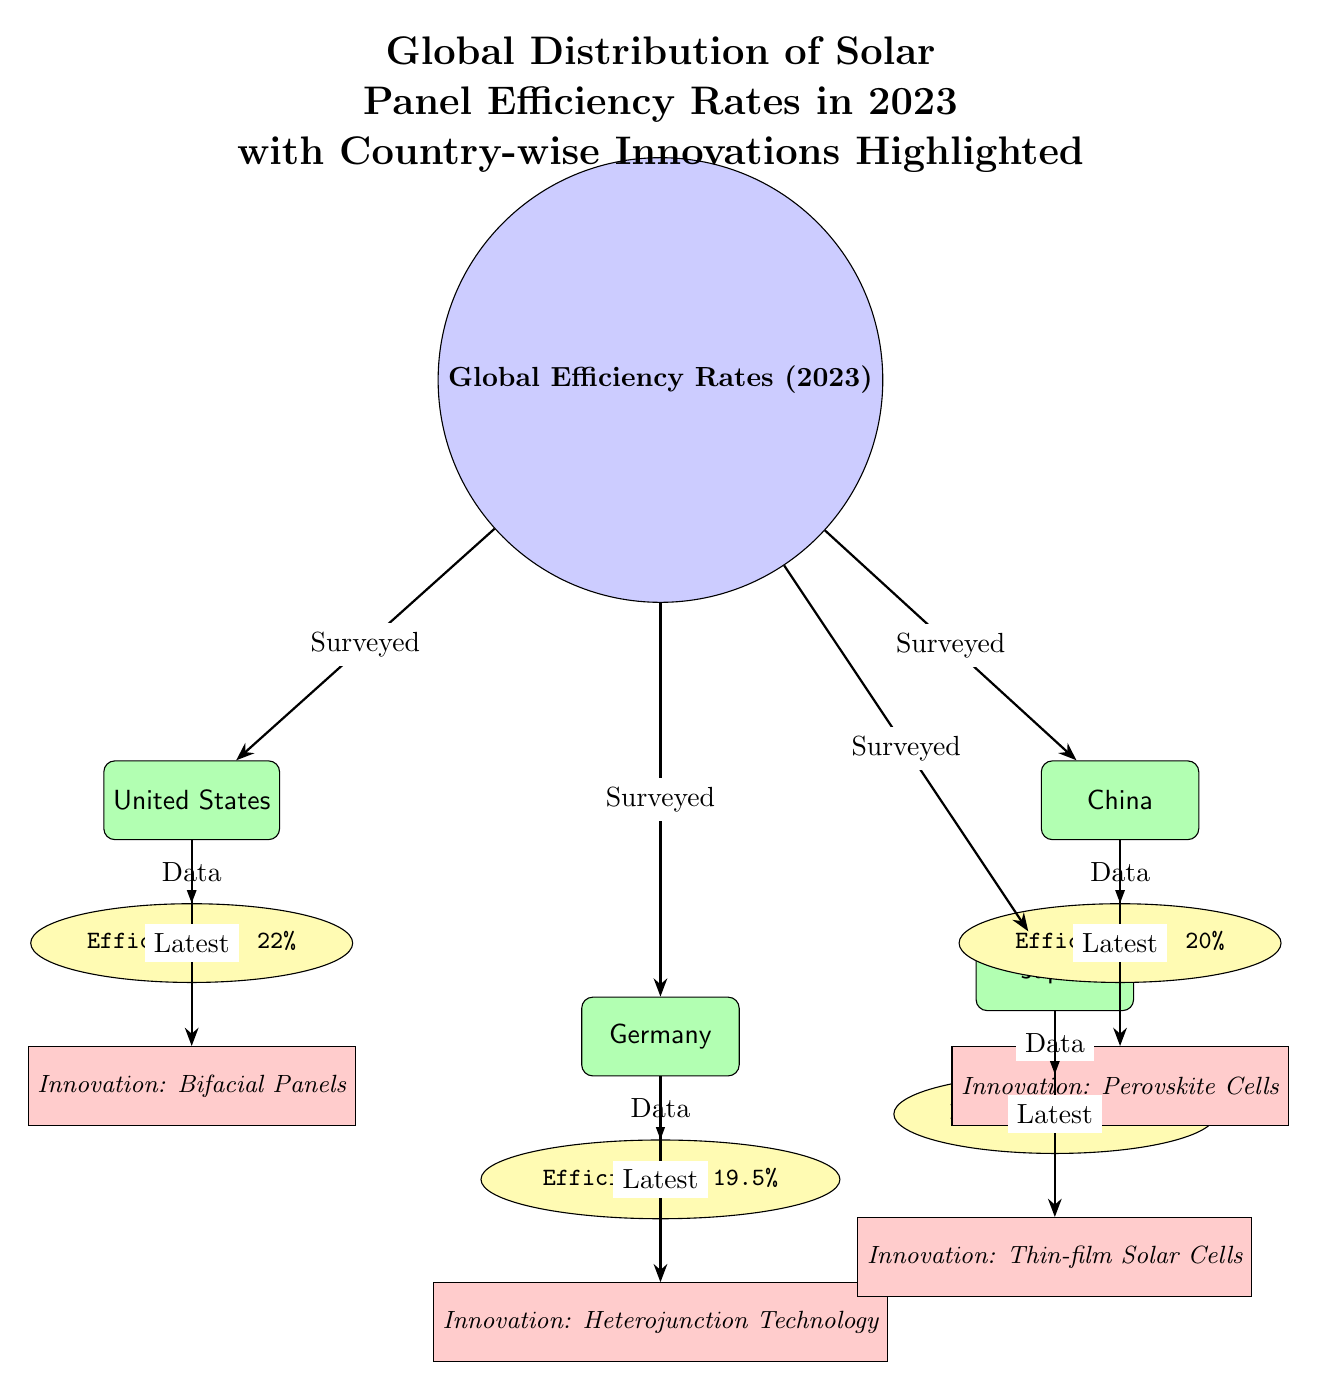What is the efficiency rate for the United States? The diagram shows a specific efficiency node connected to the United States country node. Upon reviewing, the efficiency rate for the United States is clearly stated as 22%.
Answer: 22% Which country has the highest efficiency rate? To determine the highest efficiency rate, I compare the efficiency values for each country, which are 22% for the United States, 20% for China, 19.5% for Germany, and 23% for Japan. Japan has the highest rate at 23%.
Answer: Japan What is the innovation highlighted for Germany? Looking at the innovation nodes, the one connected to Germany specifically states "Heterojunction Technology". This tells us about the latest innovation in solar panels for Germany.
Answer: Heterojunction Technology How many countries are surveyed in the diagram? The diagram displays four country nodes, which represent the surveyed countries. Counting these nodes, we find there are four countries: the United States, China, Germany, and Japan.
Answer: 4 What innovation is associated with China? By examining the innovation node connected to the China country node, I find it mentions "Perovskite Cells". This indicates the specific technological advancement associated with solar panels in China.
Answer: Perovskite Cells What is the efficiency rate for Japan? The efficiency node connected to the Japan country node indicates the efficiency rate for Japan is 23%. This is the specific value provided in the diagram.
Answer: 23% Which two countries have efficiency rates below 22%? By comparing the efficiency rates of all countries identified in the diagram—22% for the United States, 20% for China, 19.5% for Germany, and 23% for Japan—it's clear that China (20%) and Germany (19.5%) fall below the 22% threshold.
Answer: China, Germany How is the global distribution of efficiency depicted in the diagram? The diagram uses a central node marked “Global Efficiency Rates (2023)” connected with arrows to the country nodes, which in turn connect to their efficiency and innovation nodes. This structure visually represents the way efficiency rates are distributed globally among the surveyed countries.
Answer: Through connected nodes and arrows 